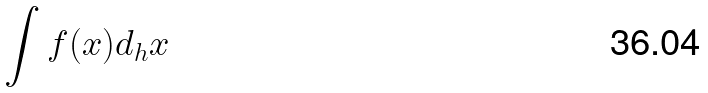<formula> <loc_0><loc_0><loc_500><loc_500>\int f ( x ) d _ { h } x</formula> 